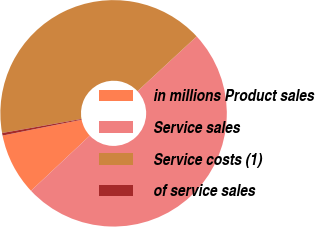Convert chart. <chart><loc_0><loc_0><loc_500><loc_500><pie_chart><fcel>in millions Product sales<fcel>Service sales<fcel>Service costs (1)<fcel>of service sales<nl><fcel>8.85%<fcel>49.89%<fcel>40.9%<fcel>0.36%<nl></chart> 